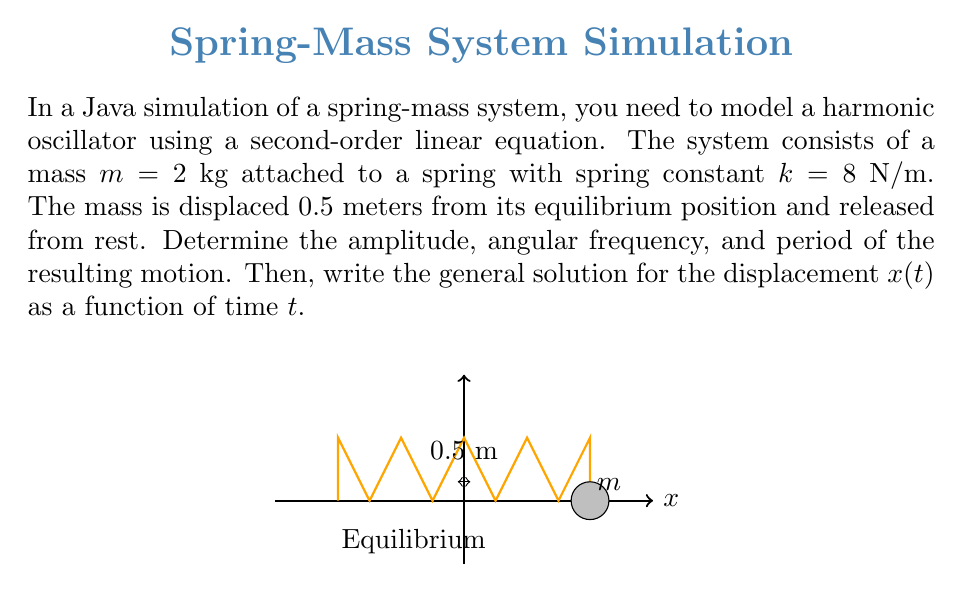Can you answer this question? To solve this problem, we'll follow these steps:

1) The general form of a second-order linear equation for a simple harmonic oscillator is:

   $$\frac{d^2x}{dt^2} + \omega^2x = 0$$

   where $\omega$ is the angular frequency.

2) For a spring-mass system, $\omega^2 = \frac{k}{m}$. Let's calculate $\omega$:

   $$\omega = \sqrt{\frac{k}{m}} = \sqrt{\frac{8}{2}} = 2 \text{ rad/s}$$

3) The amplitude $A$ is the initial displacement, which is given as 0.5 meters.

4) The period $T$ is related to the angular frequency by:

   $$T = \frac{2\pi}{\omega} = \frac{2\pi}{2} = \pi \text{ seconds}$$

5) The general solution for the displacement $x(t)$ in a simple harmonic motion is:

   $$x(t) = A\cos(\omega t + \phi)$$

   where $A$ is the amplitude, $\omega$ is the angular frequency, and $\phi$ is the phase constant.

6) Since the mass is released from rest (initial velocity is zero), we can deduce that $\phi = 0$.

Therefore, the general solution for $x(t)$ is:

$$x(t) = 0.5\cos(2t)$$

This equation represents the position of the mass as a function of time in the Java simulation.
Answer: Amplitude: 0.5 m, Angular frequency: 2 rad/s, Period: $\pi$ s, $x(t) = 0.5\cos(2t)$ 